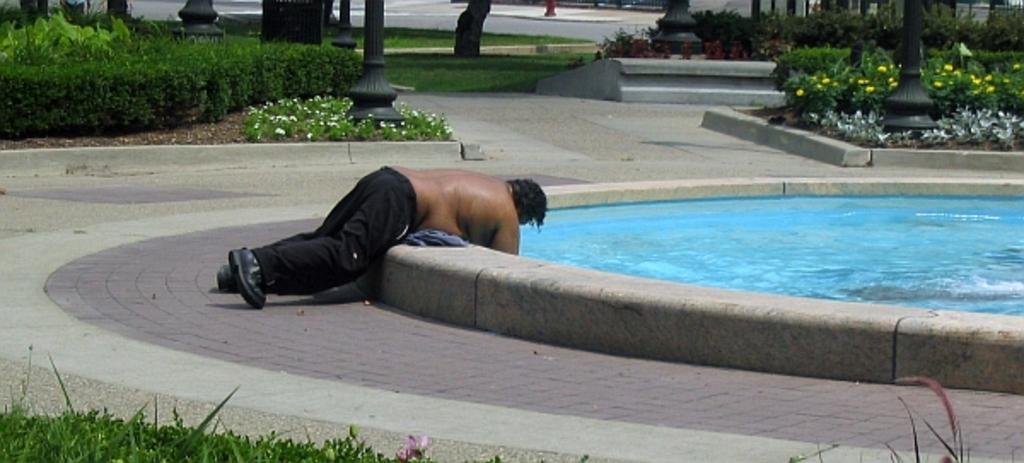Could you give a brief overview of what you see in this image? In this image we can see a person lying on the pavement of a swimming pool. In the background we can see bushes, plants, flowers, pillars and road. 